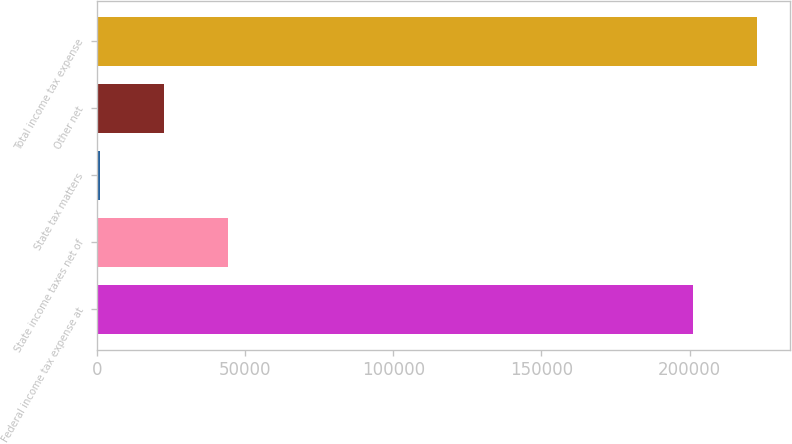Convert chart. <chart><loc_0><loc_0><loc_500><loc_500><bar_chart><fcel>Federal income tax expense at<fcel>State income taxes net of<fcel>State tax matters<fcel>Other net<fcel>Total income tax expense<nl><fcel>201278<fcel>44020<fcel>737<fcel>22378.5<fcel>222920<nl></chart> 